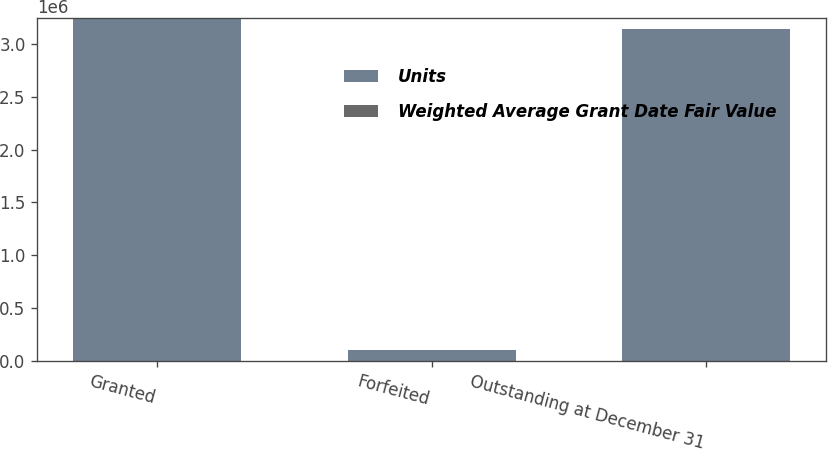Convert chart to OTSL. <chart><loc_0><loc_0><loc_500><loc_500><stacked_bar_chart><ecel><fcel>Granted<fcel>Forfeited<fcel>Outstanding at December 31<nl><fcel>Units<fcel>3.24632e+06<fcel>106200<fcel>3.14012e+06<nl><fcel>Weighted Average Grant Date Fair Value<fcel>25.45<fcel>25.54<fcel>25.44<nl></chart> 